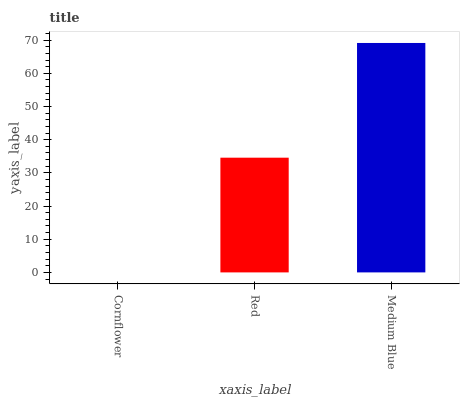Is Cornflower the minimum?
Answer yes or no. Yes. Is Medium Blue the maximum?
Answer yes or no. Yes. Is Red the minimum?
Answer yes or no. No. Is Red the maximum?
Answer yes or no. No. Is Red greater than Cornflower?
Answer yes or no. Yes. Is Cornflower less than Red?
Answer yes or no. Yes. Is Cornflower greater than Red?
Answer yes or no. No. Is Red less than Cornflower?
Answer yes or no. No. Is Red the high median?
Answer yes or no. Yes. Is Red the low median?
Answer yes or no. Yes. Is Cornflower the high median?
Answer yes or no. No. Is Medium Blue the low median?
Answer yes or no. No. 